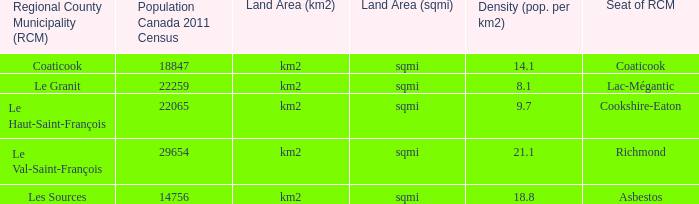What is the land area for the RCM that has a population of 18847? Km2 (sqmi). 